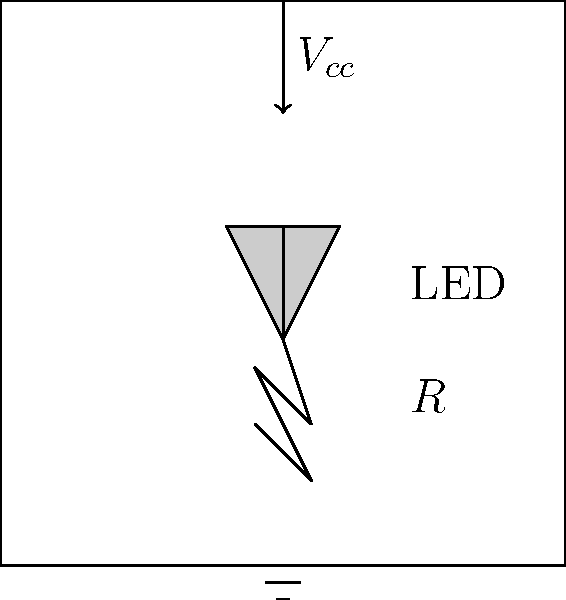As a car dealership owner, you want to upgrade the interior lighting of your vehicles with LED strips. Design a basic LED circuit for a 12V car electrical system. If the forward voltage of each LED is 2V and the desired current through each LED is 20mA, what value of series resistor (R) should be used for a single LED? To determine the appropriate resistor value, we'll follow these steps:

1. Identify the given values:
   - Supply voltage (${V_{cc}}$) = 12V (car's electrical system)
   - LED forward voltage (${V_f}$) = 2V
   - Desired LED current (${I_{LED}}$) = 20mA = 0.02A

2. Calculate the voltage drop across the resistor:
   ${V_R} = {V_{cc}} - {V_f} = 12V - 2V = 10V$

3. Use Ohm's Law to calculate the resistor value:
   $R = \frac{V_R}{I_{LED}} = \frac{10V}{0.02A} = 500\Omega$

4. Round to the nearest standard resistor value:
   The closest standard resistor value is 510Ω.

Therefore, a 510Ω resistor should be used in series with the LED to limit the current to approximately 20mA in a 12V car electrical system.
Answer: 510Ω 